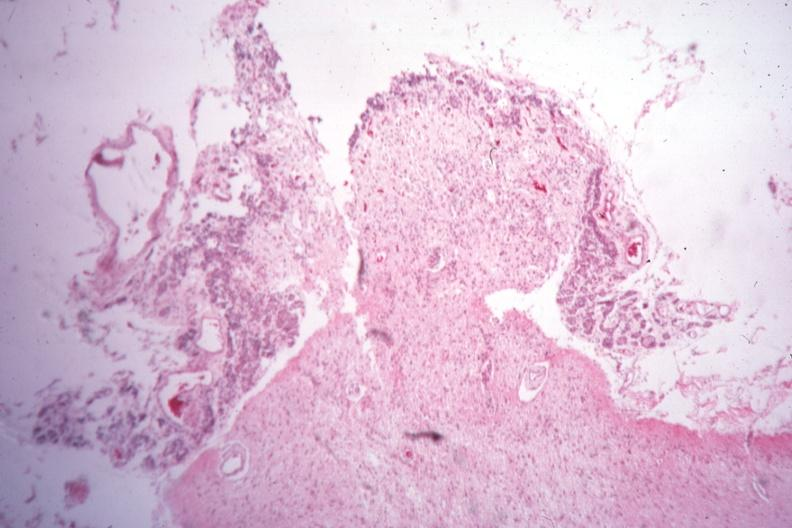s slide present?
Answer the question using a single word or phrase. No 